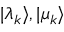Convert formula to latex. <formula><loc_0><loc_0><loc_500><loc_500>| \lambda _ { k } \rangle , | \mu _ { k } \rangle</formula> 